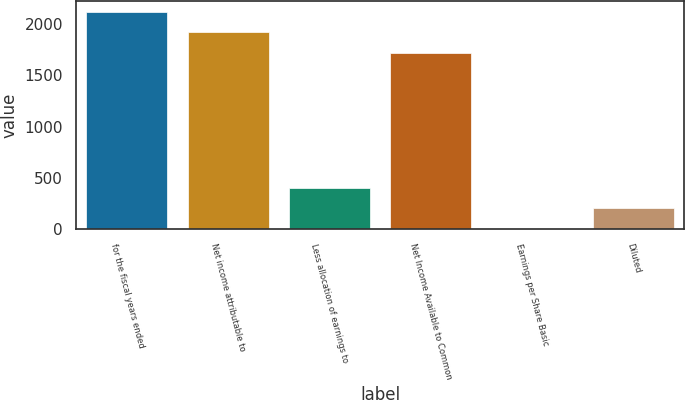Convert chart. <chart><loc_0><loc_0><loc_500><loc_500><bar_chart><fcel>for the fiscal years ended<fcel>Net income attributable to<fcel>Less allocation of earnings to<fcel>Net Income Available to Common<fcel>Earnings per Share Basic<fcel>Diluted<nl><fcel>2118.42<fcel>1917.11<fcel>405.56<fcel>1715.8<fcel>2.94<fcel>204.25<nl></chart> 